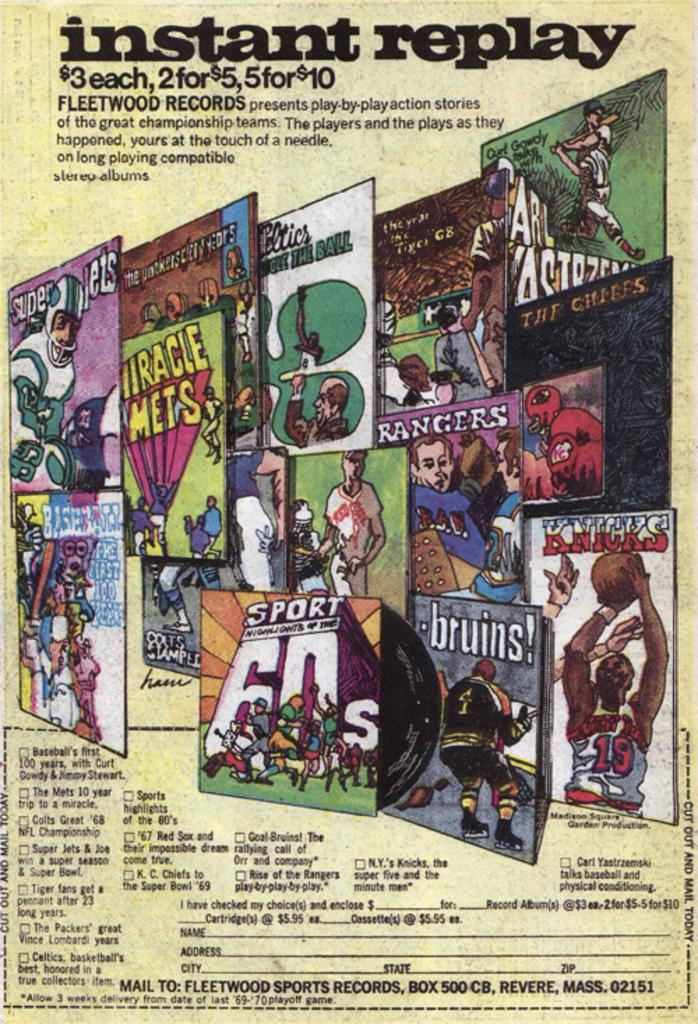<image>
Share a concise interpretation of the image provided. A poster titled Instant Replay and the price for their products. 